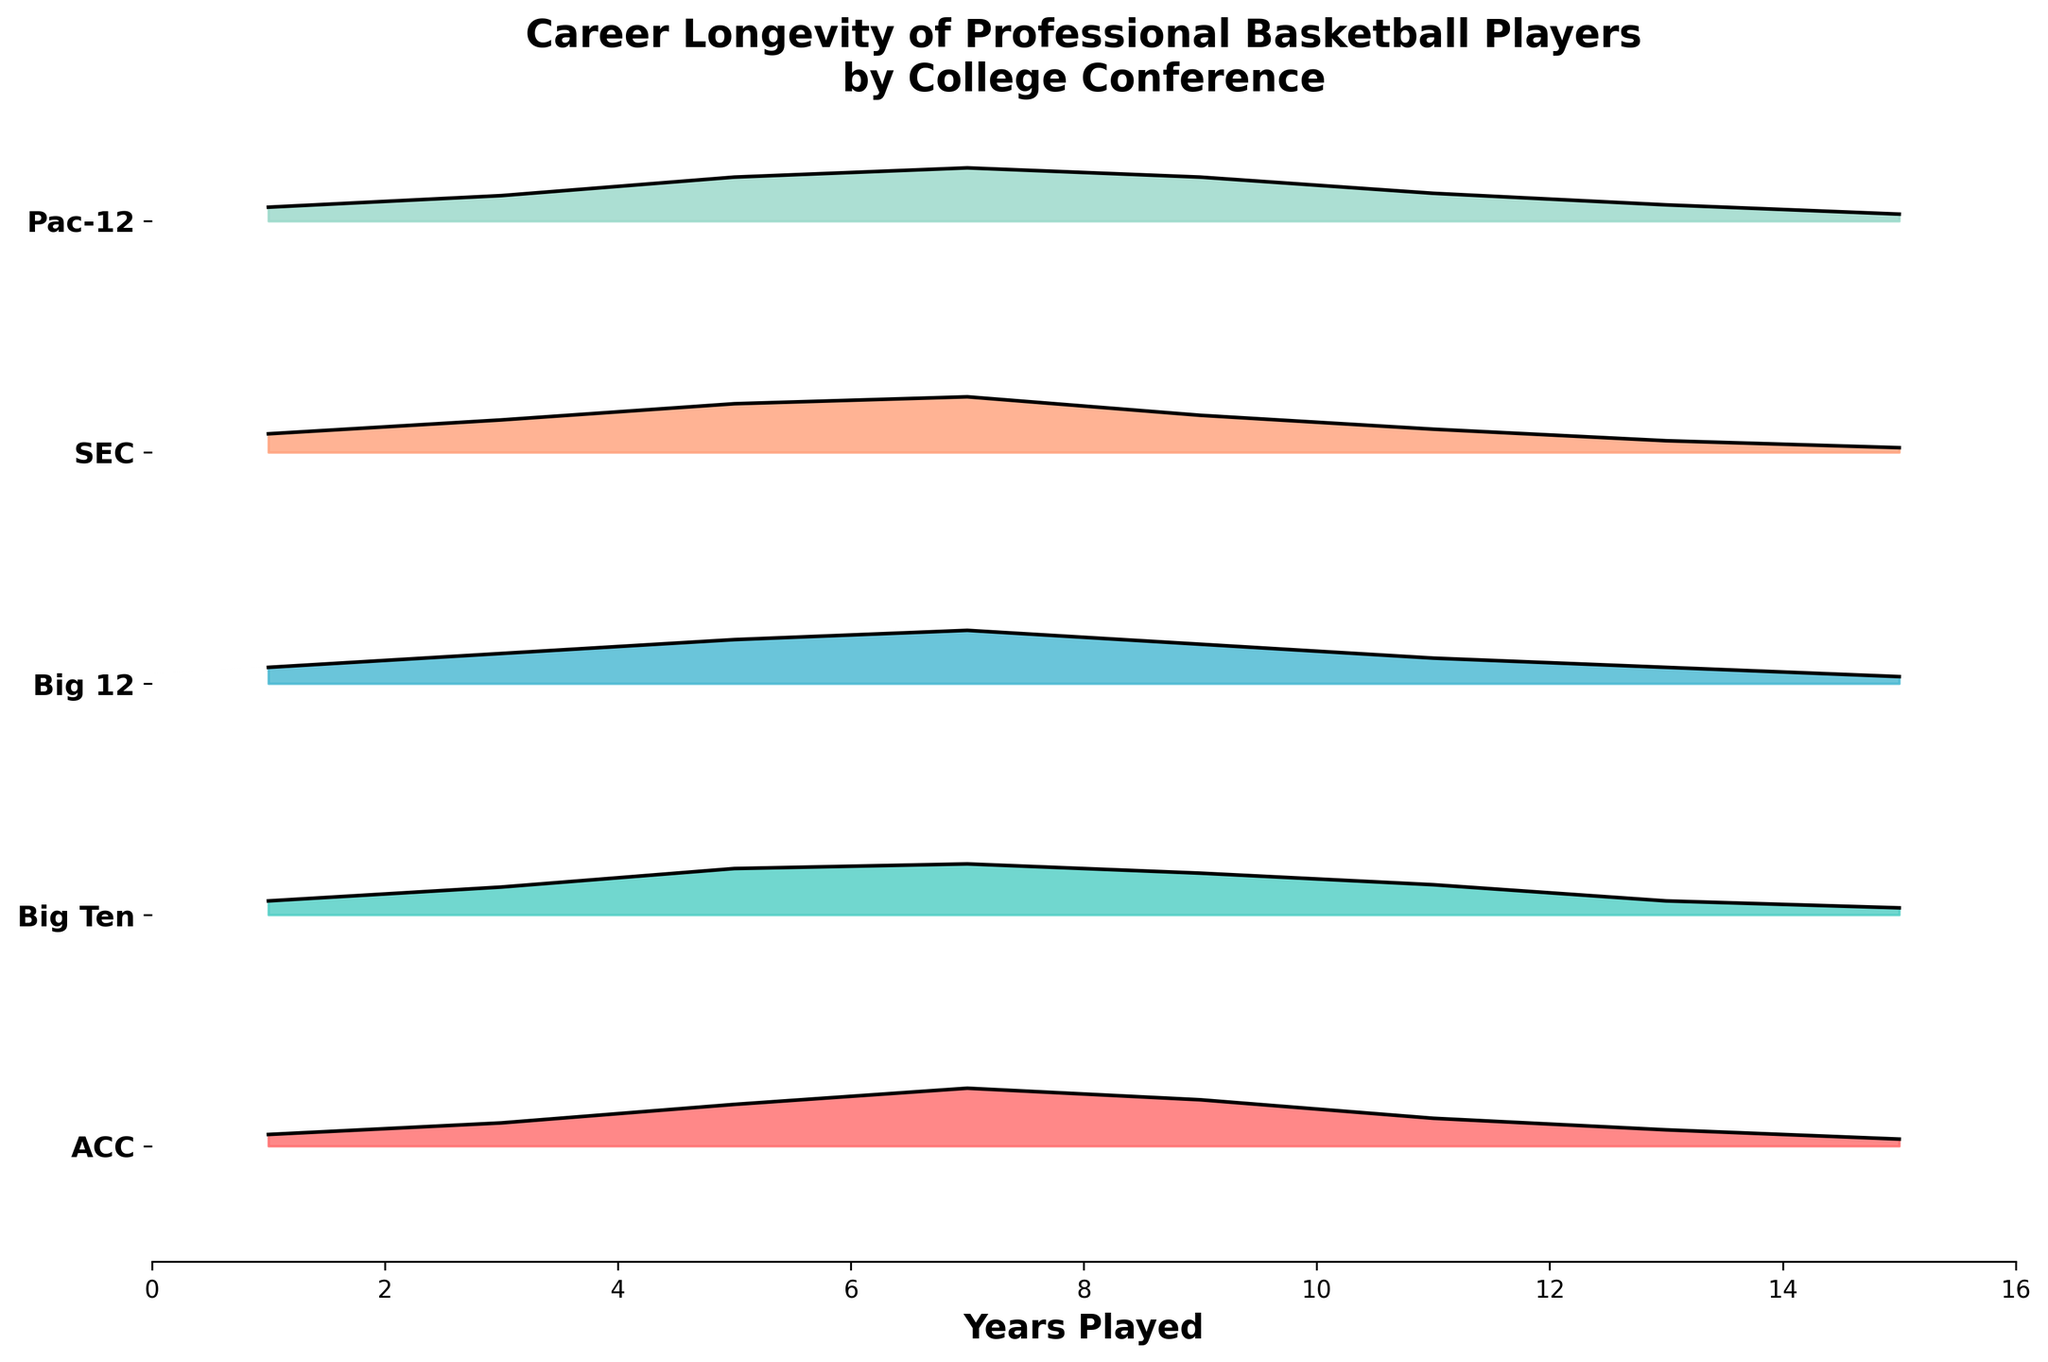What's the title of the figure? The title is displayed at the top of the figure and summarizes the content of the plot.
Answer: Career Longevity of Professional Basketball Players by College Conference Which college conference shows the highest density of players with 11 years of career longevity? Look at the plot and identify the conference where the density curve peaks highest at the 11-year mark.
Answer: Pac-12 Which conference has the broadest spread of career longevity (more varied years played)? Total spread can be identified by examining the width of the density curve for each conference.
Answer: SEC What is the most common career duration for players in the Big Ten conference? Observe the peak of the density curve for the Big Ten conference to find the most frequent career length.
Answer: 7 years Among ACC, Big Ten, and SEC, which conference has the least density of players with 1 year of career longevity? Compare the height of the density curves at the 1-year mark for ACC, Big Ten, and SEC.
Answer: ACC Which conference has a higher density of players with a career length of 9 years, ACC or SEC? Compare the height of the density curves at the 9-year mark for ACC and SEC.
Answer: ACC How many conferences have their peak density at 7 years of career longevity? Count the number of density curves that peak at the 7-year mark.
Answer: 5 Which conference shows a gradual decrease in density after 7 years of career longevity? Identify the density curve that gradually decreases after reaching 7 years.
Answer: All conferences show this pattern What range of years is generally covered in the plot for all conferences? Look at the x-axis range covered by the density curves for all the conferences.
Answer: 1 to 15 years Do any conference curves overlap at any point, and if so, which ones? Observe the plot to see if any density curves intersect at any career length (years).
Answer: Yes, multiple curves overlap 